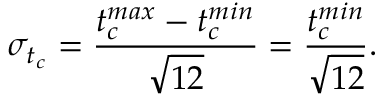Convert formula to latex. <formula><loc_0><loc_0><loc_500><loc_500>\sigma _ { t _ { c } } = \frac { t _ { c } ^ { \max } - t _ { c } ^ { \min } } { \sqrt { 1 2 } } = \frac { t _ { c } ^ { \min } } { \sqrt { 1 2 } } .</formula> 